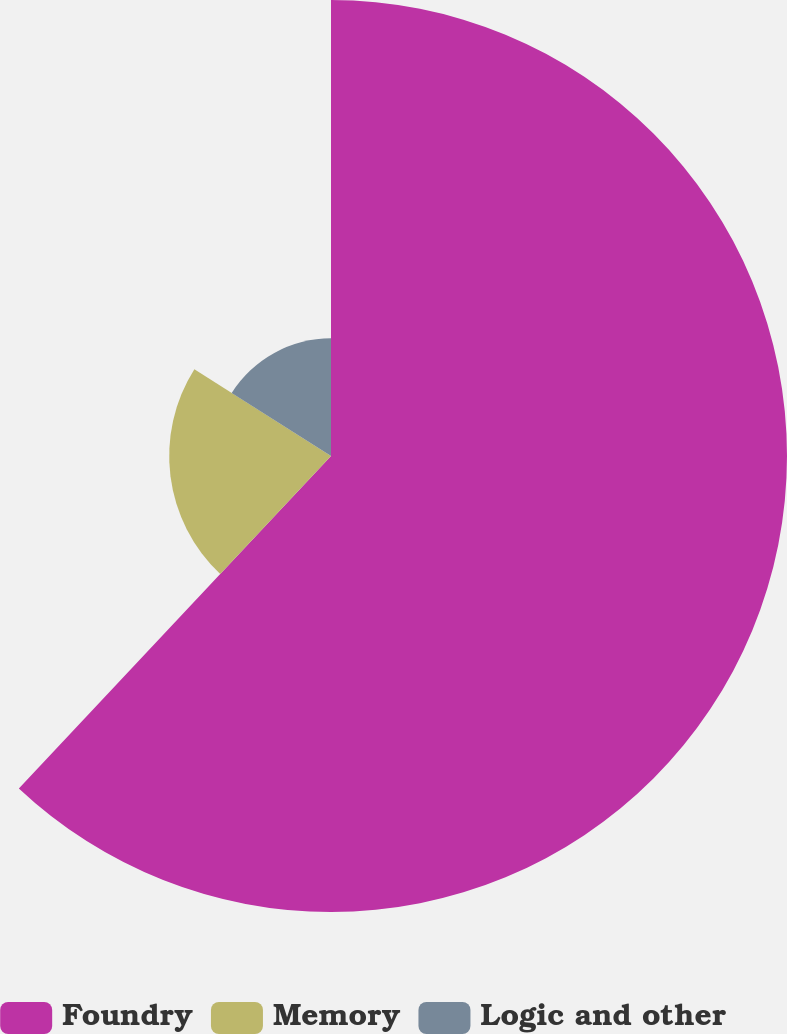<chart> <loc_0><loc_0><loc_500><loc_500><pie_chart><fcel>Foundry<fcel>Memory<fcel>Logic and other<nl><fcel>62.0%<fcel>22.0%<fcel>16.0%<nl></chart> 